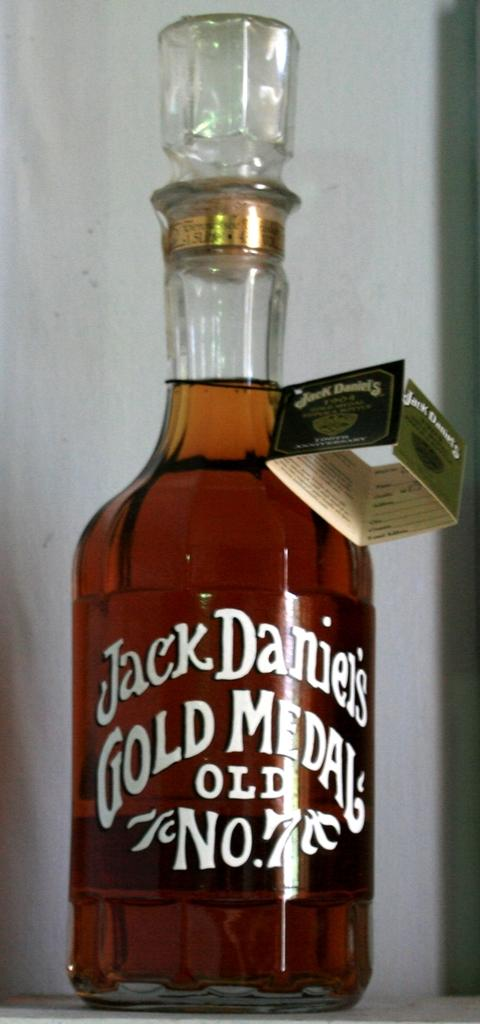What type of container is present in the image? There is a wine glass bottle in the image. What type of crow is depicted in the frame in the image? There is no crow or frame present in the image; it only features a wine glass bottle. 